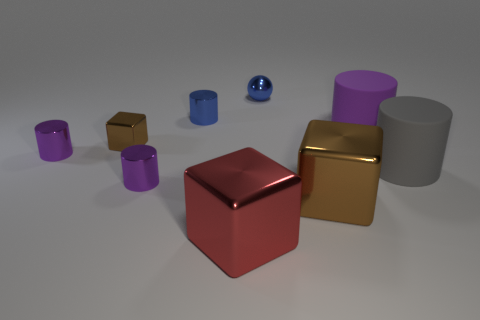Can you tell me how many objects are in this image and describe their shapes? There are eight objects in the image. Starting from the left, there are three cylindrical objects, the first two being smaller and purple, the third being larger and gray. Next, there's a small gold cube, followed by a large red cube and a large gold cube. Lastly, there are a small brown cube and a small blue sphere. 